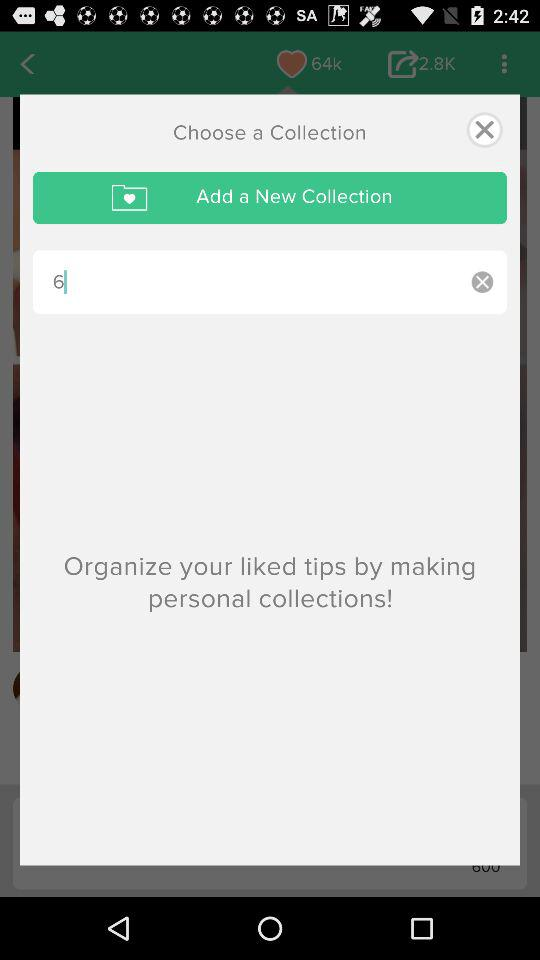How many times has it been shared? It has been shared 2800 times. 